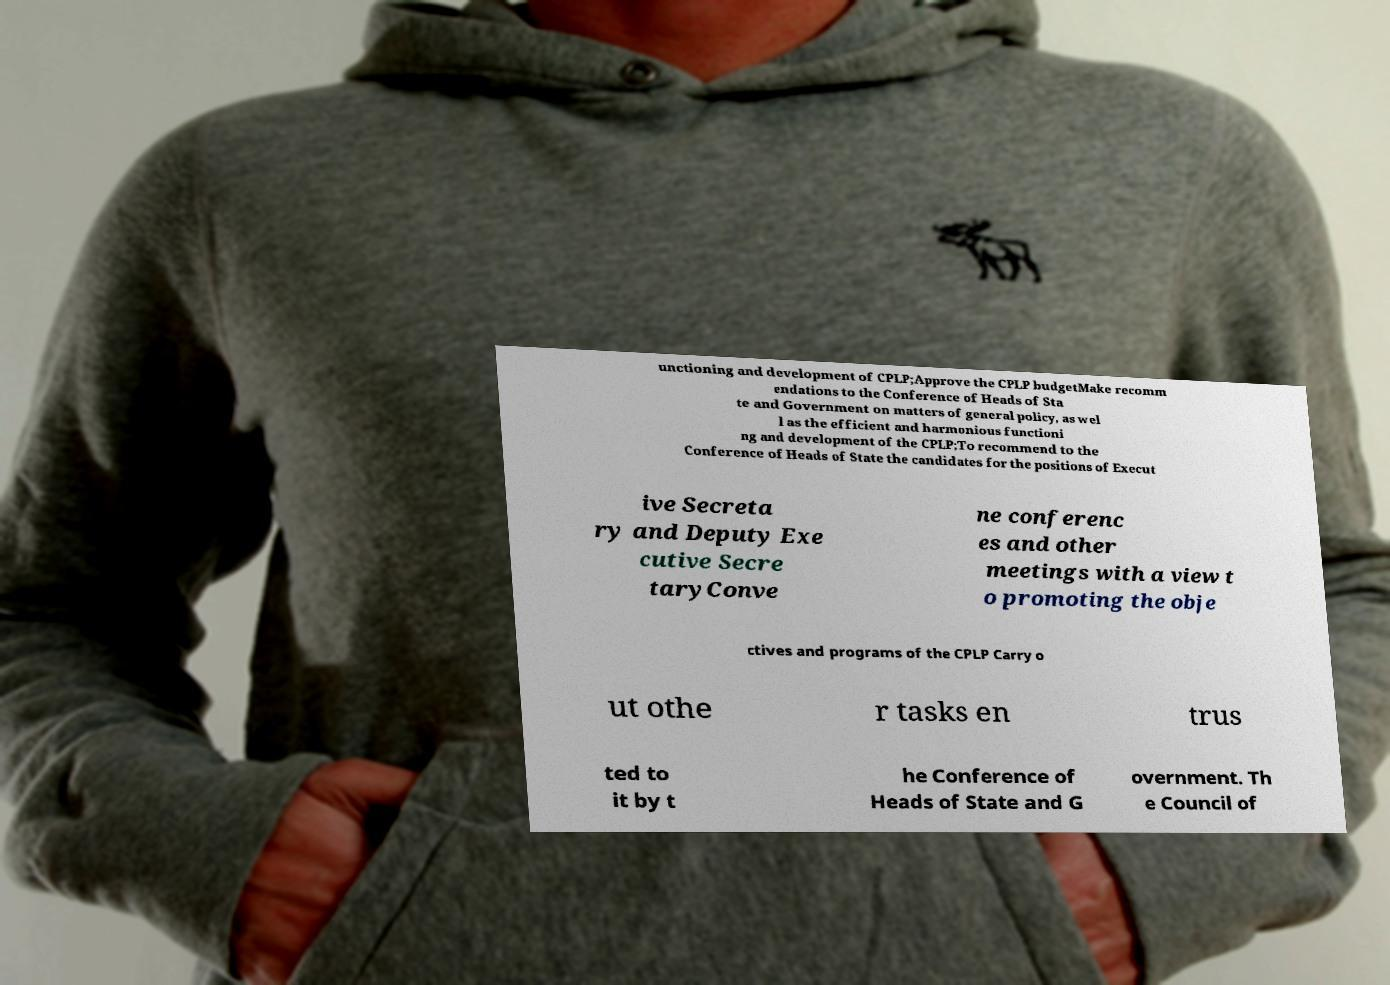For documentation purposes, I need the text within this image transcribed. Could you provide that? unctioning and development of CPLP;Approve the CPLP budgetMake recomm endations to the Conference of Heads of Sta te and Government on matters of general policy, as wel l as the efficient and harmonious functioni ng and development of the CPLP;To recommend to the Conference of Heads of State the candidates for the positions of Execut ive Secreta ry and Deputy Exe cutive Secre taryConve ne conferenc es and other meetings with a view t o promoting the obje ctives and programs of the CPLP Carry o ut othe r tasks en trus ted to it by t he Conference of Heads of State and G overnment. Th e Council of 